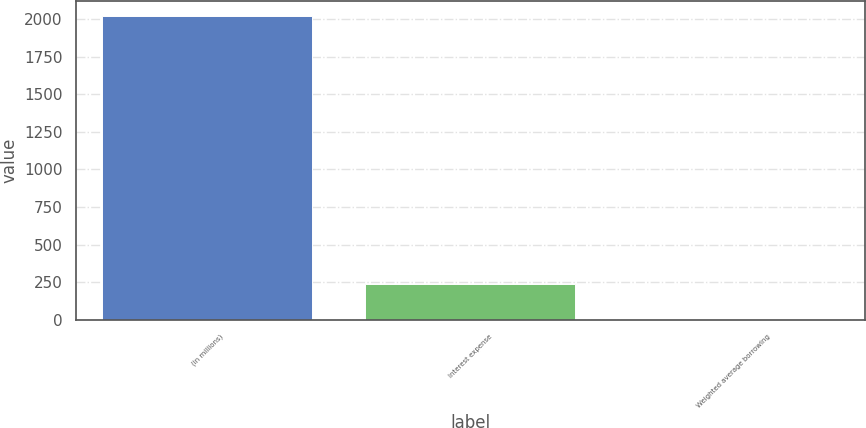<chart> <loc_0><loc_0><loc_500><loc_500><bar_chart><fcel>(in millions)<fcel>Interest expense<fcel>Weighted average borrowing<nl><fcel>2018<fcel>241<fcel>3.6<nl></chart> 